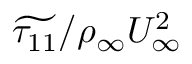<formula> <loc_0><loc_0><loc_500><loc_500>\widetilde { \tau _ { 1 1 } } / \rho _ { \infty } U _ { \infty } ^ { 2 }</formula> 